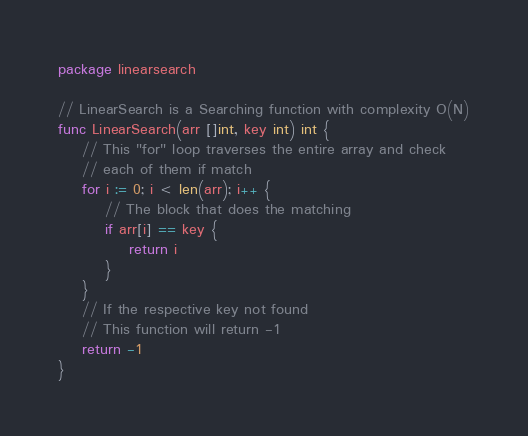<code> <loc_0><loc_0><loc_500><loc_500><_Go_>package linearsearch

// LinearSearch is a Searching function with complexity O(N)
func LinearSearch(arr []int, key int) int {
	// This "for" loop traverses the entire array and check
	// each of them if match
	for i := 0; i < len(arr); i++ {
		// The block that does the matching
		if arr[i] == key {
			return i
		}
	}
	// If the respective key not found
	// This function will return -1
	return -1
}
</code> 